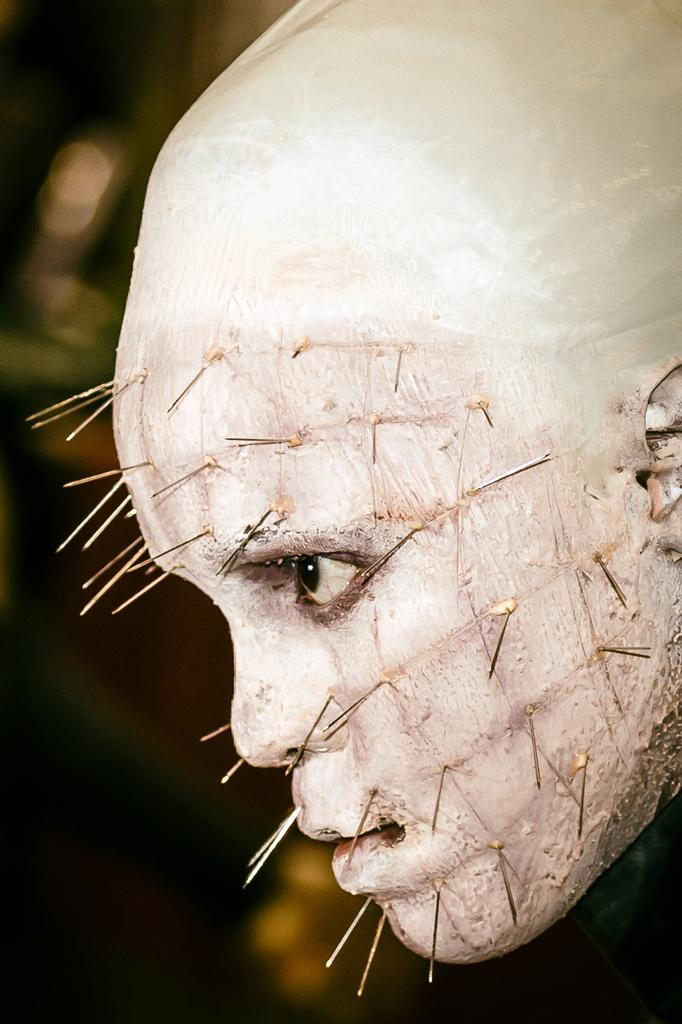What is the main subject of the image? The main subject of the image is a man's face. In which direction is the man's face turned? The man's face is turned to the right. What is attached to the man's face in the image? There are needles attached to the man's face. What type of bait is being used on the cannon in the image? There is no cannon or bait present in the image; it features a man's face with needles attached. 